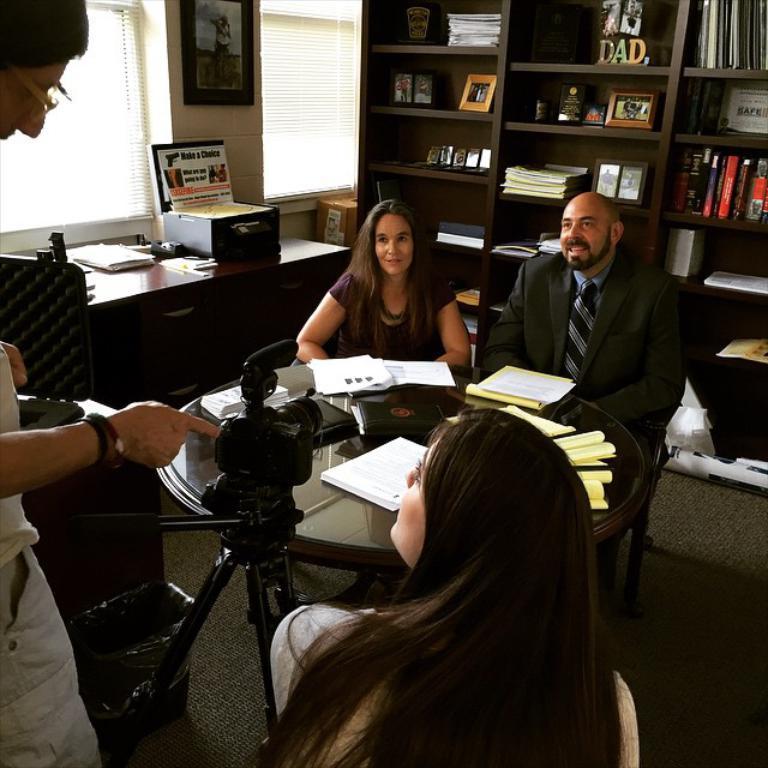Can you describe this image briefly? In this image i can see there are group of people, among them three people are sitting on a chair and a man is talking to a woman. We also have a table with a few objects on it. Behind these people we have a shelf in which there are some objects on it and I can also see a camera on the floor. 